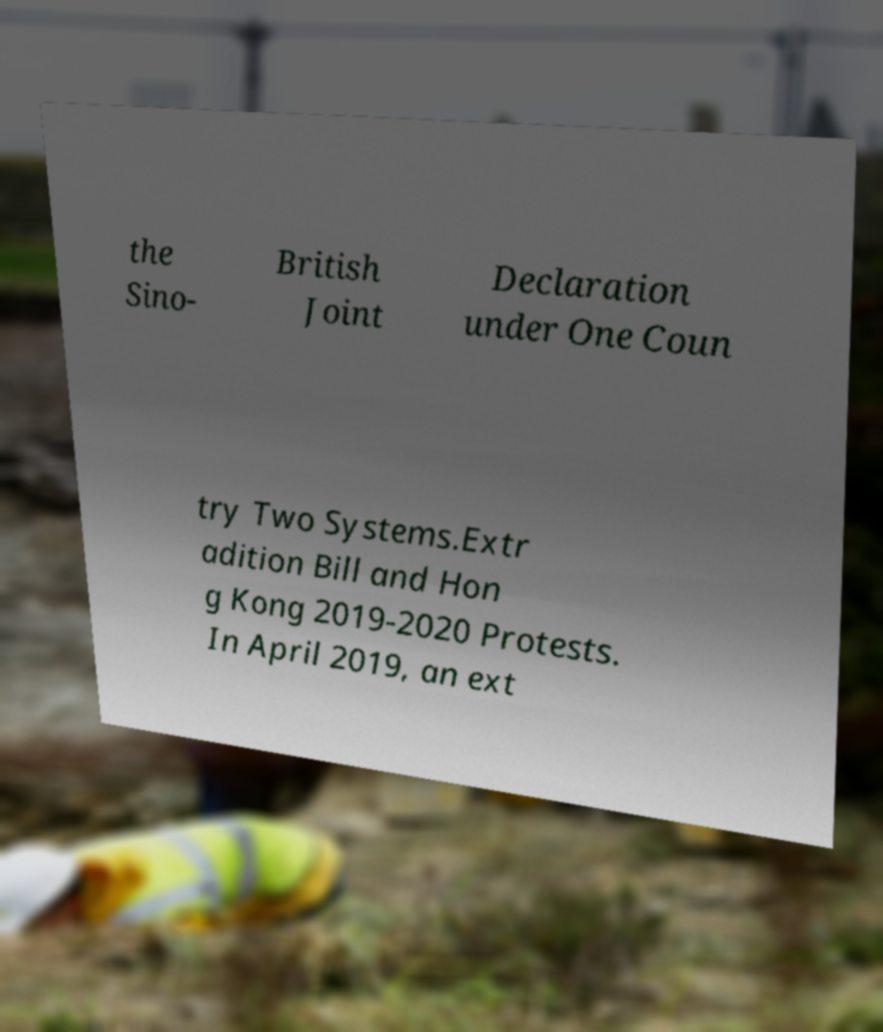Please identify and transcribe the text found in this image. the Sino- British Joint Declaration under One Coun try Two Systems.Extr adition Bill and Hon g Kong 2019-2020 Protests. In April 2019, an ext 